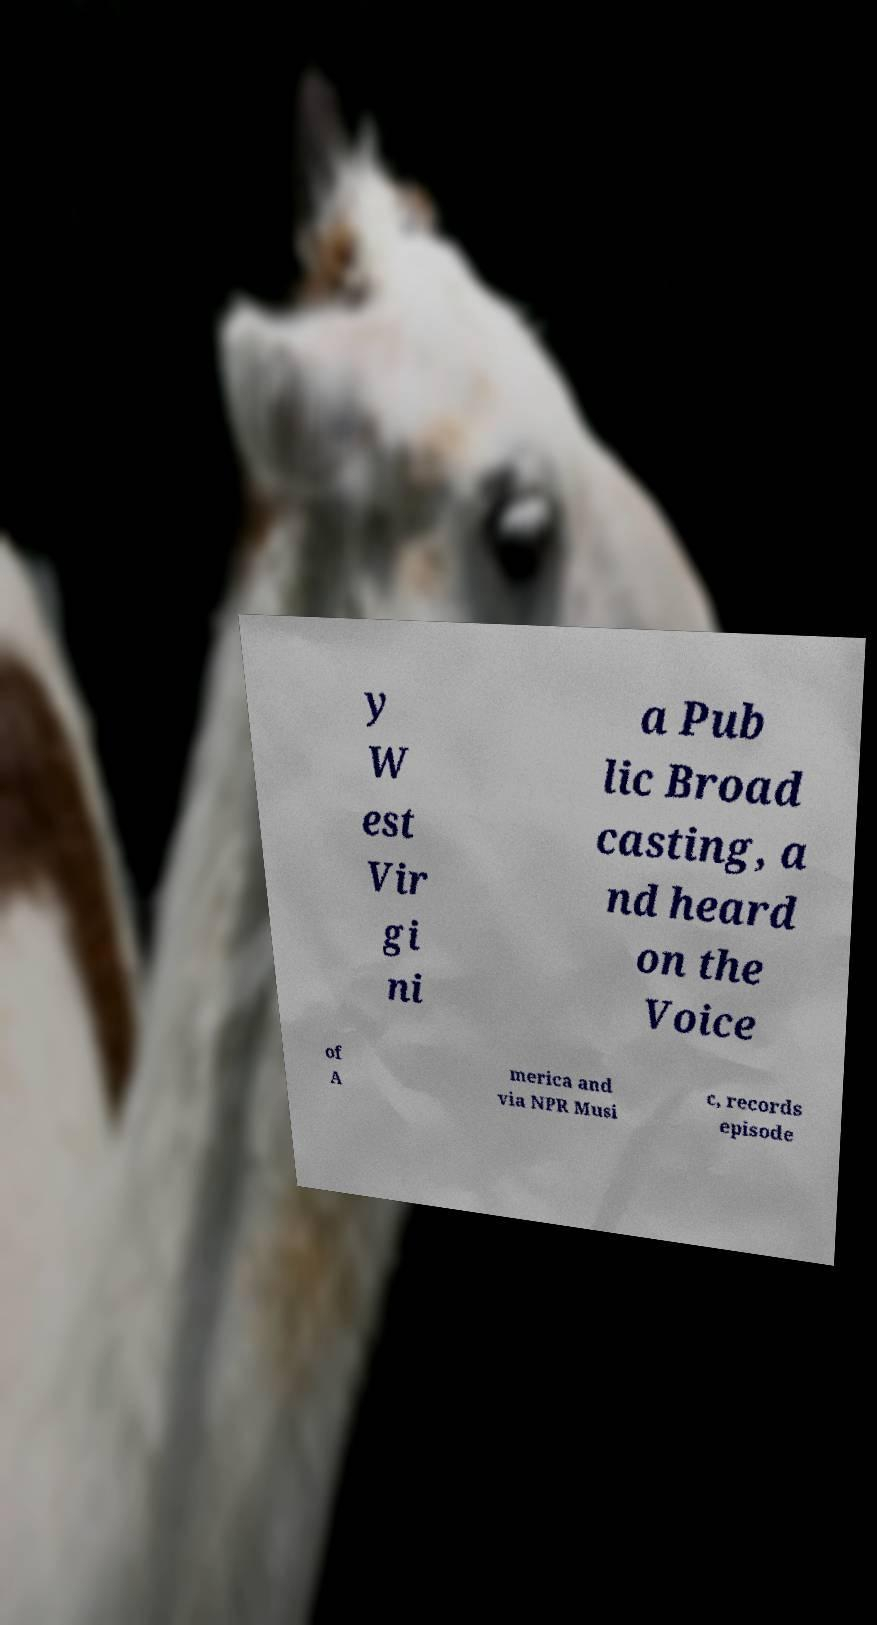For documentation purposes, I need the text within this image transcribed. Could you provide that? y W est Vir gi ni a Pub lic Broad casting, a nd heard on the Voice of A merica and via NPR Musi c, records episode 